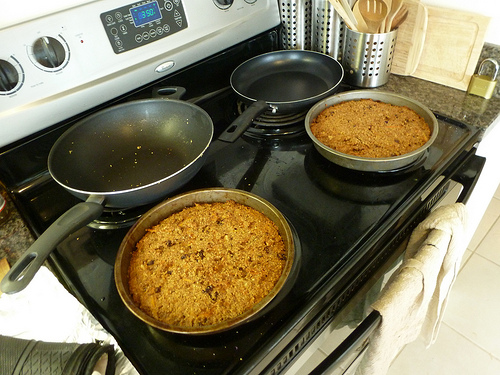<image>
Is the pan on the floor? No. The pan is not positioned on the floor. They may be near each other, but the pan is not supported by or resting on top of the floor. Where is the range in relation to the pan? Is it above the pan? No. The range is not positioned above the pan. The vertical arrangement shows a different relationship. 